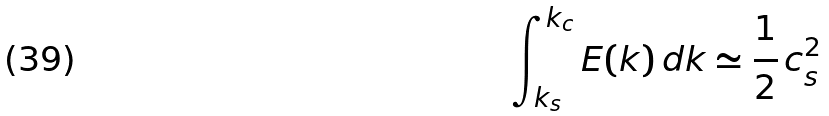<formula> <loc_0><loc_0><loc_500><loc_500>\int _ { k _ { s } } ^ { k _ { c } } E ( k ) \, d k \simeq \frac { 1 } { 2 } \, c _ { s } ^ { 2 }</formula> 